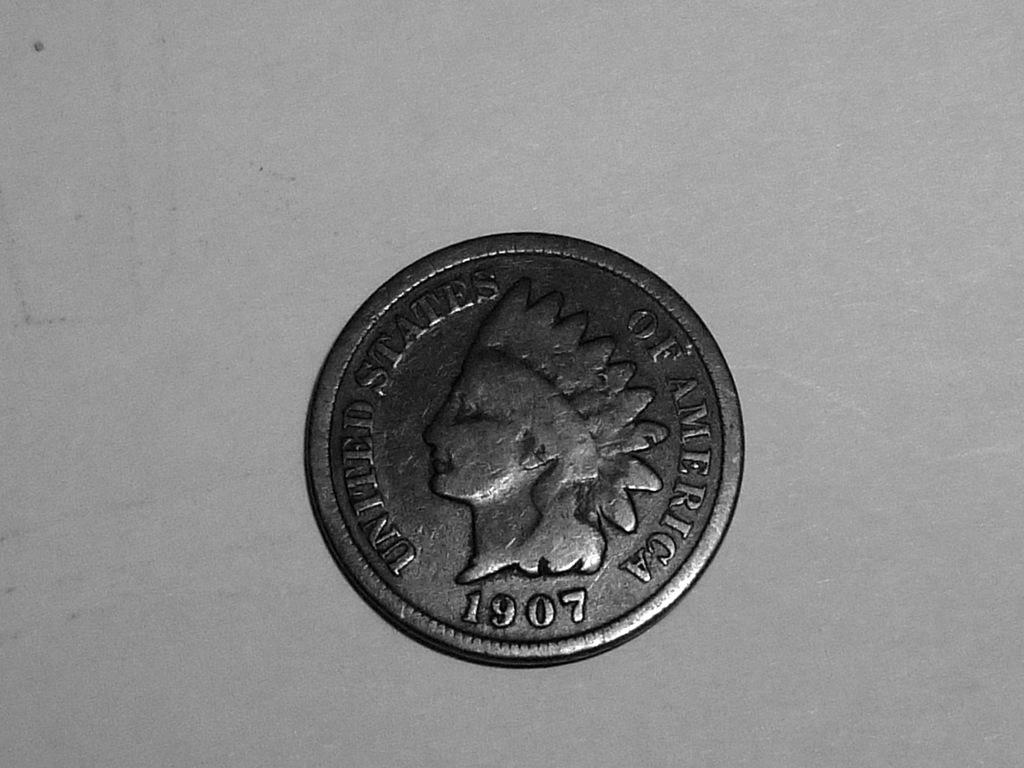<image>
Provide a brief description of the given image. A silver coin from The United States of America is shown on a light surface. 